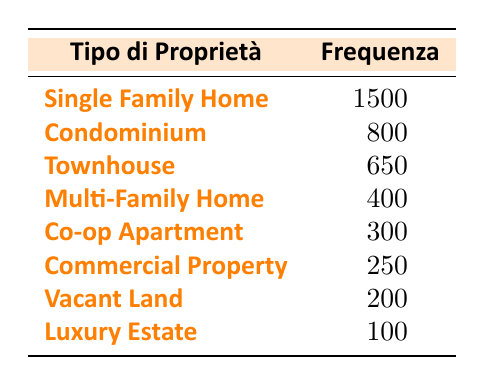What is the total number of Single Family Homes sold in 2022? According to the table, the sold count for Single Family Homes is listed as 1500, which represents the total number of this property type sold in 2022.
Answer: 1500 How many more Condominiums were sold compared to Multi-Family Homes? From the table, 800 Condominiums and 400 Multi-Family Homes were sold. The difference is calculated by subtracting the sold count of Multi-Family Homes from Condominiums: 800 - 400 = 400.
Answer: 400 Is the sold count of Luxury Estates greater than that of Vacant Land? The table lists 100 sold Luxury Estates and 200 sold Vacant Lands. Since 100 is less than 200, the statement is false.
Answer: No Which property type had the second-highest number of sales? The table indicates that Single Family Homes had the highest sold count at 1500, and Condominiums had the next highest at 800. Hence, the second-highest number of sales is for Condominiums.
Answer: Condominium What is the total number of properties sold across all types listed in the table? To find the total, we sum all the sold counts: 1500 + 800 + 650 + 400 + 300 + 250 + 200 + 100 = 4150. Therefore, the total number of properties sold is 4150.
Answer: 4150 How many property types had a sold count of less than 500? Referring to the table, the property types with sold counts below 500 are Multi-Family Homes (400), Commercial Property (250), Vacant Land (200), and Luxury Estates (100). That gives us 4 property types.
Answer: 4 What is the average number of sales for the property types listed? To calculate the average, sum all sold counts (4150) and divide by the number of property types (8): 4150 / 8 = 518.75. Therefore, the average number of sales per property type is 518.75.
Answer: 518.75 Did Co-op Apartments sell more than Commercial Properties and Vacant Lands combined? Co-op Apartments sold 300, while Commercial Properties sold 250 and Vacant Lands sold 200. The sum for Commercial Properties and Vacant Lands is 250 + 200 = 450, which is greater than 300. Therefore, the statement is false.
Answer: No 